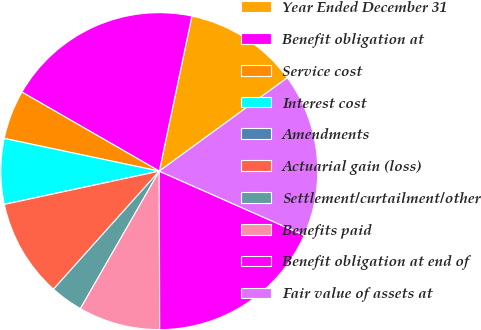<chart> <loc_0><loc_0><loc_500><loc_500><pie_chart><fcel>Year Ended December 31<fcel>Benefit obligation at<fcel>Service cost<fcel>Interest cost<fcel>Amendments<fcel>Actuarial gain (loss)<fcel>Settlement/curtailment/other<fcel>Benefits paid<fcel>Benefit obligation at end of<fcel>Fair value of assets at<nl><fcel>11.67%<fcel>19.99%<fcel>5.0%<fcel>6.67%<fcel>0.01%<fcel>10.0%<fcel>3.34%<fcel>8.33%<fcel>18.33%<fcel>16.66%<nl></chart> 